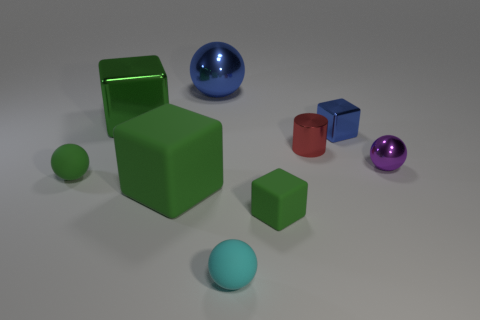Is the color of the metal cylinder the same as the metallic sphere in front of the big blue shiny ball?
Offer a terse response. No. There is a tiny block that is behind the metal sphere in front of the red thing; what is its color?
Keep it short and to the point. Blue. What is the color of the other rubber ball that is the same size as the green rubber sphere?
Provide a succinct answer. Cyan. Are there any matte objects of the same shape as the tiny red shiny thing?
Offer a terse response. No. The cyan object is what shape?
Offer a terse response. Sphere. Are there more purple spheres left of the tiny blue metal cube than matte spheres that are to the right of the red thing?
Offer a very short reply. No. How many other objects are the same size as the blue block?
Your response must be concise. 5. What material is the small object that is right of the shiny cylinder and left of the purple metallic object?
Your answer should be compact. Metal. What is the material of the tiny green object that is the same shape as the purple metallic thing?
Keep it short and to the point. Rubber. There is a green cube that is behind the ball right of the tiny blue shiny thing; how many big green matte things are on the left side of it?
Your answer should be very brief. 0. 